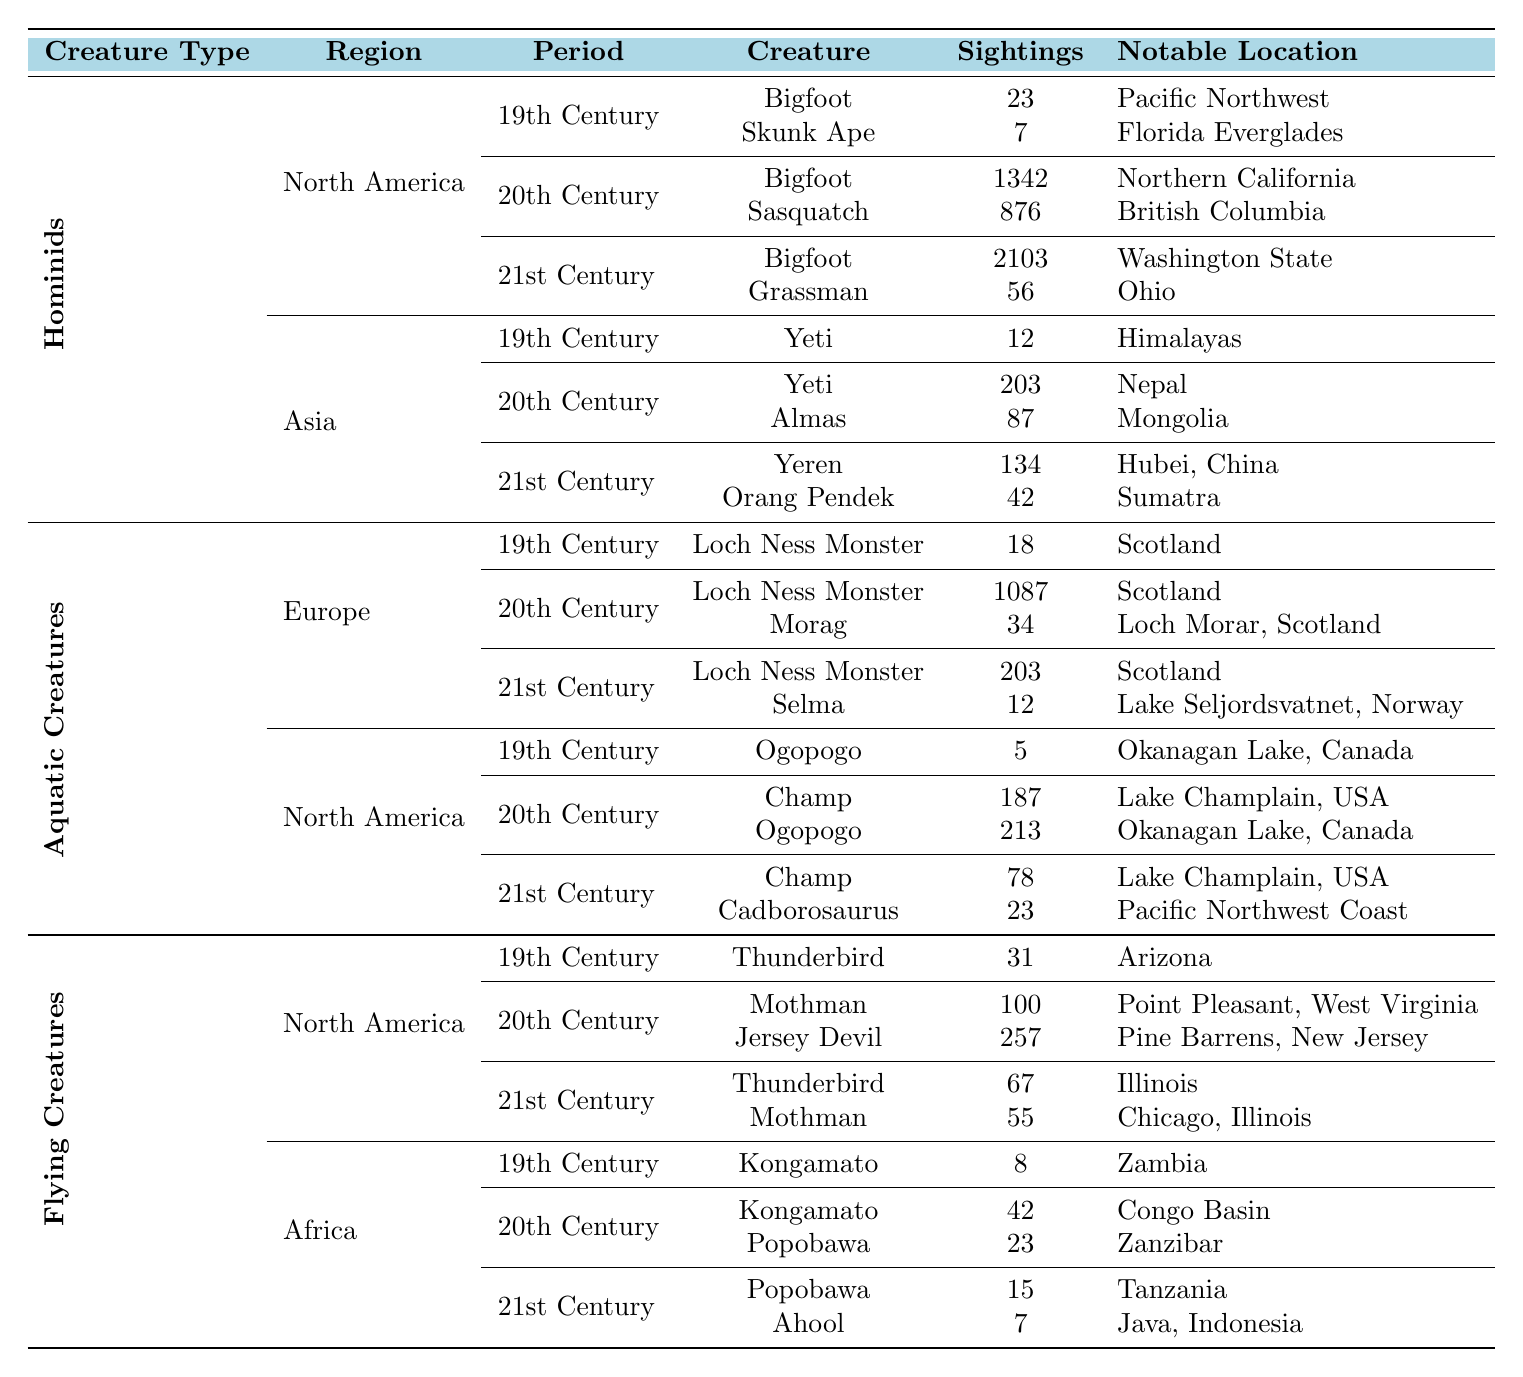What is the creature with the highest number of sightings in North America during the 21st century? According to the table, Bigfoot has 2103 sightings in North America during the 21st century, which is higher than any other creature listed.
Answer: Bigfoot How many total sightings of the Loch Ness Monster have been recorded across all centuries in Europe? The sightings of the Loch Ness Monster in Europe are: 18 (19th Century), 1087 (20th Century), and 203 (21st Century). Summing them up gives 18 + 1087 + 203 = 1308.
Answer: 1308 In which region did Skunk Ape have its sightings, and how many were reported in the 19th century? Skunk Ape was sighted only in North America, with 7 sightings reported in the 19th century as per the table.
Answer: North America, 7 sightings What is the difference in the number of sightings of Yeti between the 20th and 21st centuries in Asia? In the 20th century, Yeti had 203 sightings, whereas in the 21st century, it had 134 sightings. The difference is 203 - 134 = 69.
Answer: 69 Is there any creature listed in the table that has recorded sightings in Africa during the 21st century? Yes, the Popobawa and Ahool have recorded sightings in Africa during the 21st century, confirming the presence of creatures in that category.
Answer: Yes What creature has the most sightings in Europe during the 20th century, and how many sightings were recorded? In Europe during the 20th century, the Loch Ness Monster has the most sightings at 1087, which is more than any other creature listed.
Answer: Loch Ness Monster, 1087 sightings How many sightings were recorded for Aquatic Creatures in North America during the 20th century? The table shows that Champ had 187 sightings and Ogopogo had 213 sightings in North America during the 20th century. The total is 187 + 213 = 400 sightings.
Answer: 400 What is the average number of sightings for Hominids in Asia across all recorded centuries? The sightings for Hominids in Asia are: 12 (19th Century), 203 (20th Century), and 134 (21st Century). The total is 12 + 203 + 134 = 349, with three data points for the average: 349 / 3 = 116.33, round to 116.
Answer: 116 Which creature had the lowest number of sightings in the 19th century and what was the count? According to the table, Ogopogo in North America had the lowest number of sightings in the 19th century with only 5 sightings recorded.
Answer: Ogopogo, 5 sightings Is the number of sightings for Mothman higher in the 21st century compared to the 20th century? No, in the 20th century, Mothman had 100 sightings, while in the 21st century it had only 55 sightings, indicating a decline in sightings.
Answer: No 